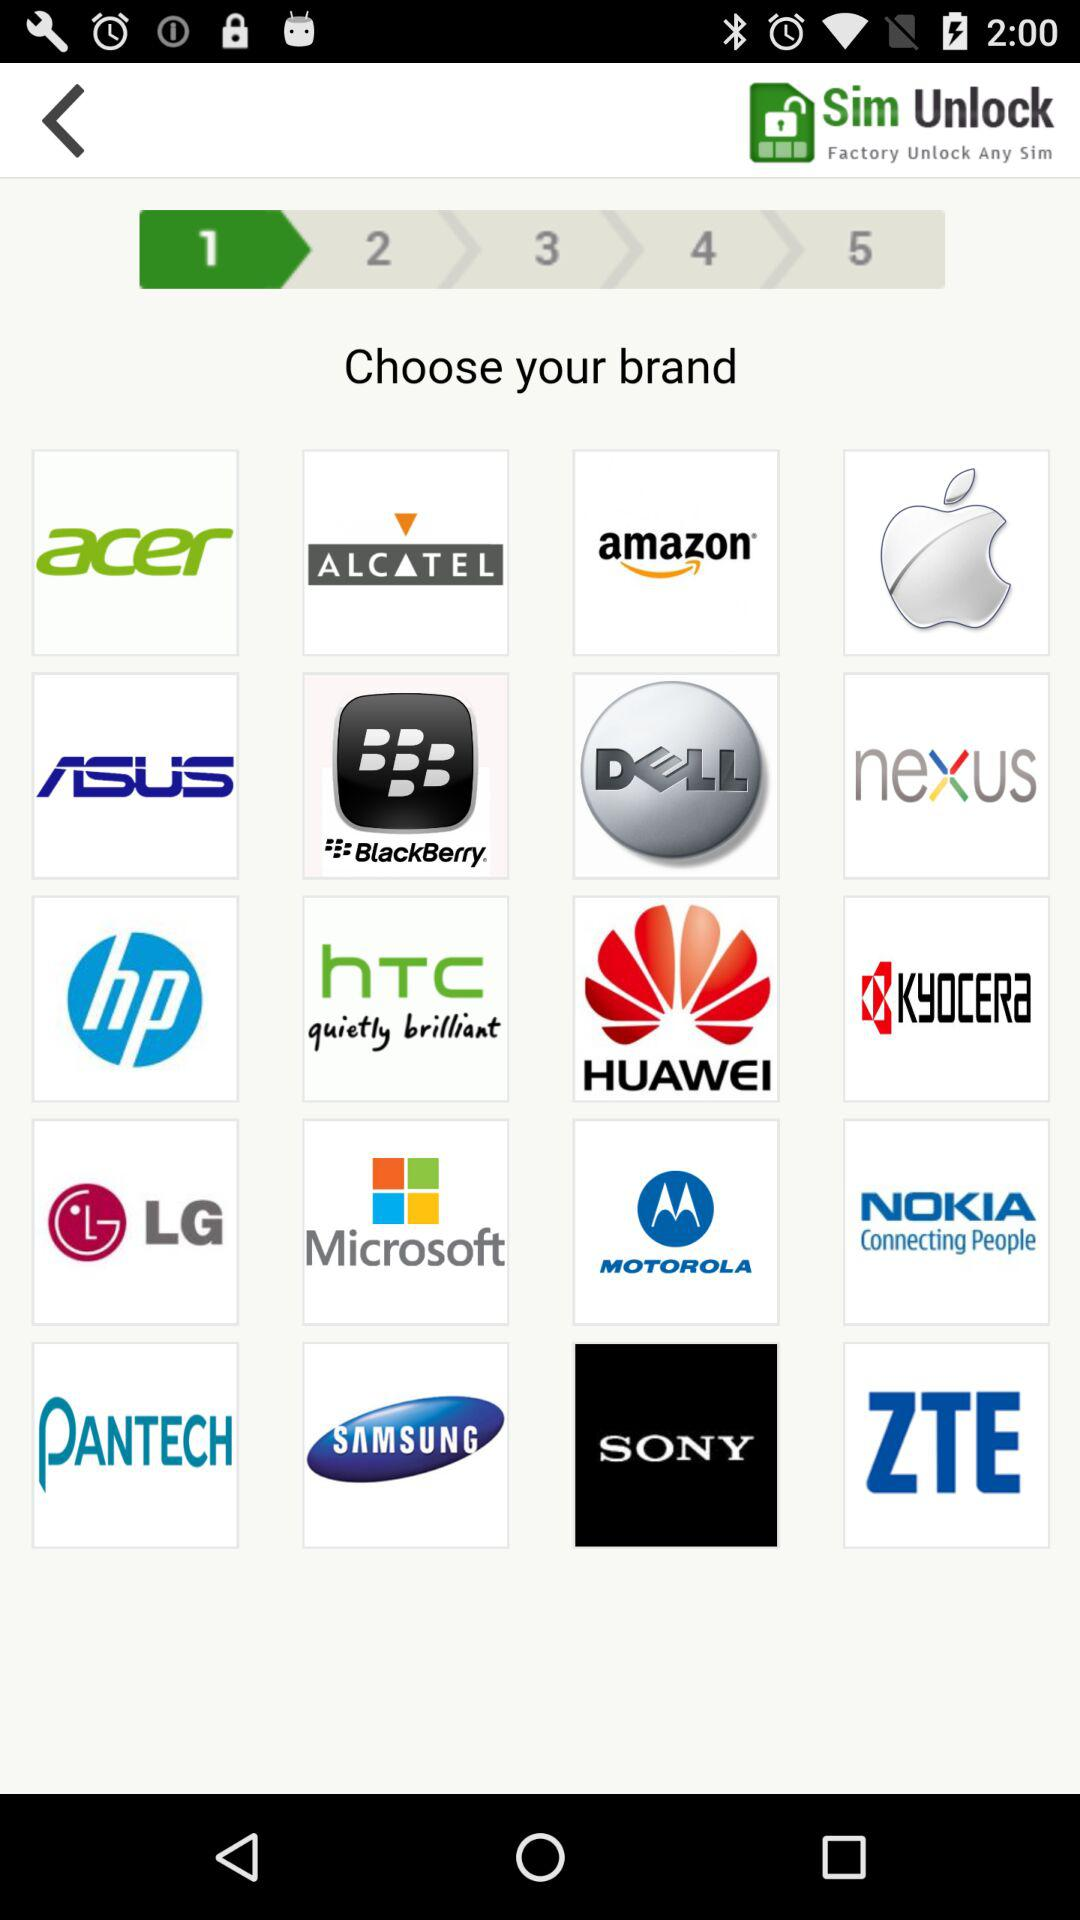How many pages in total are there? There are 5 pages in total. 